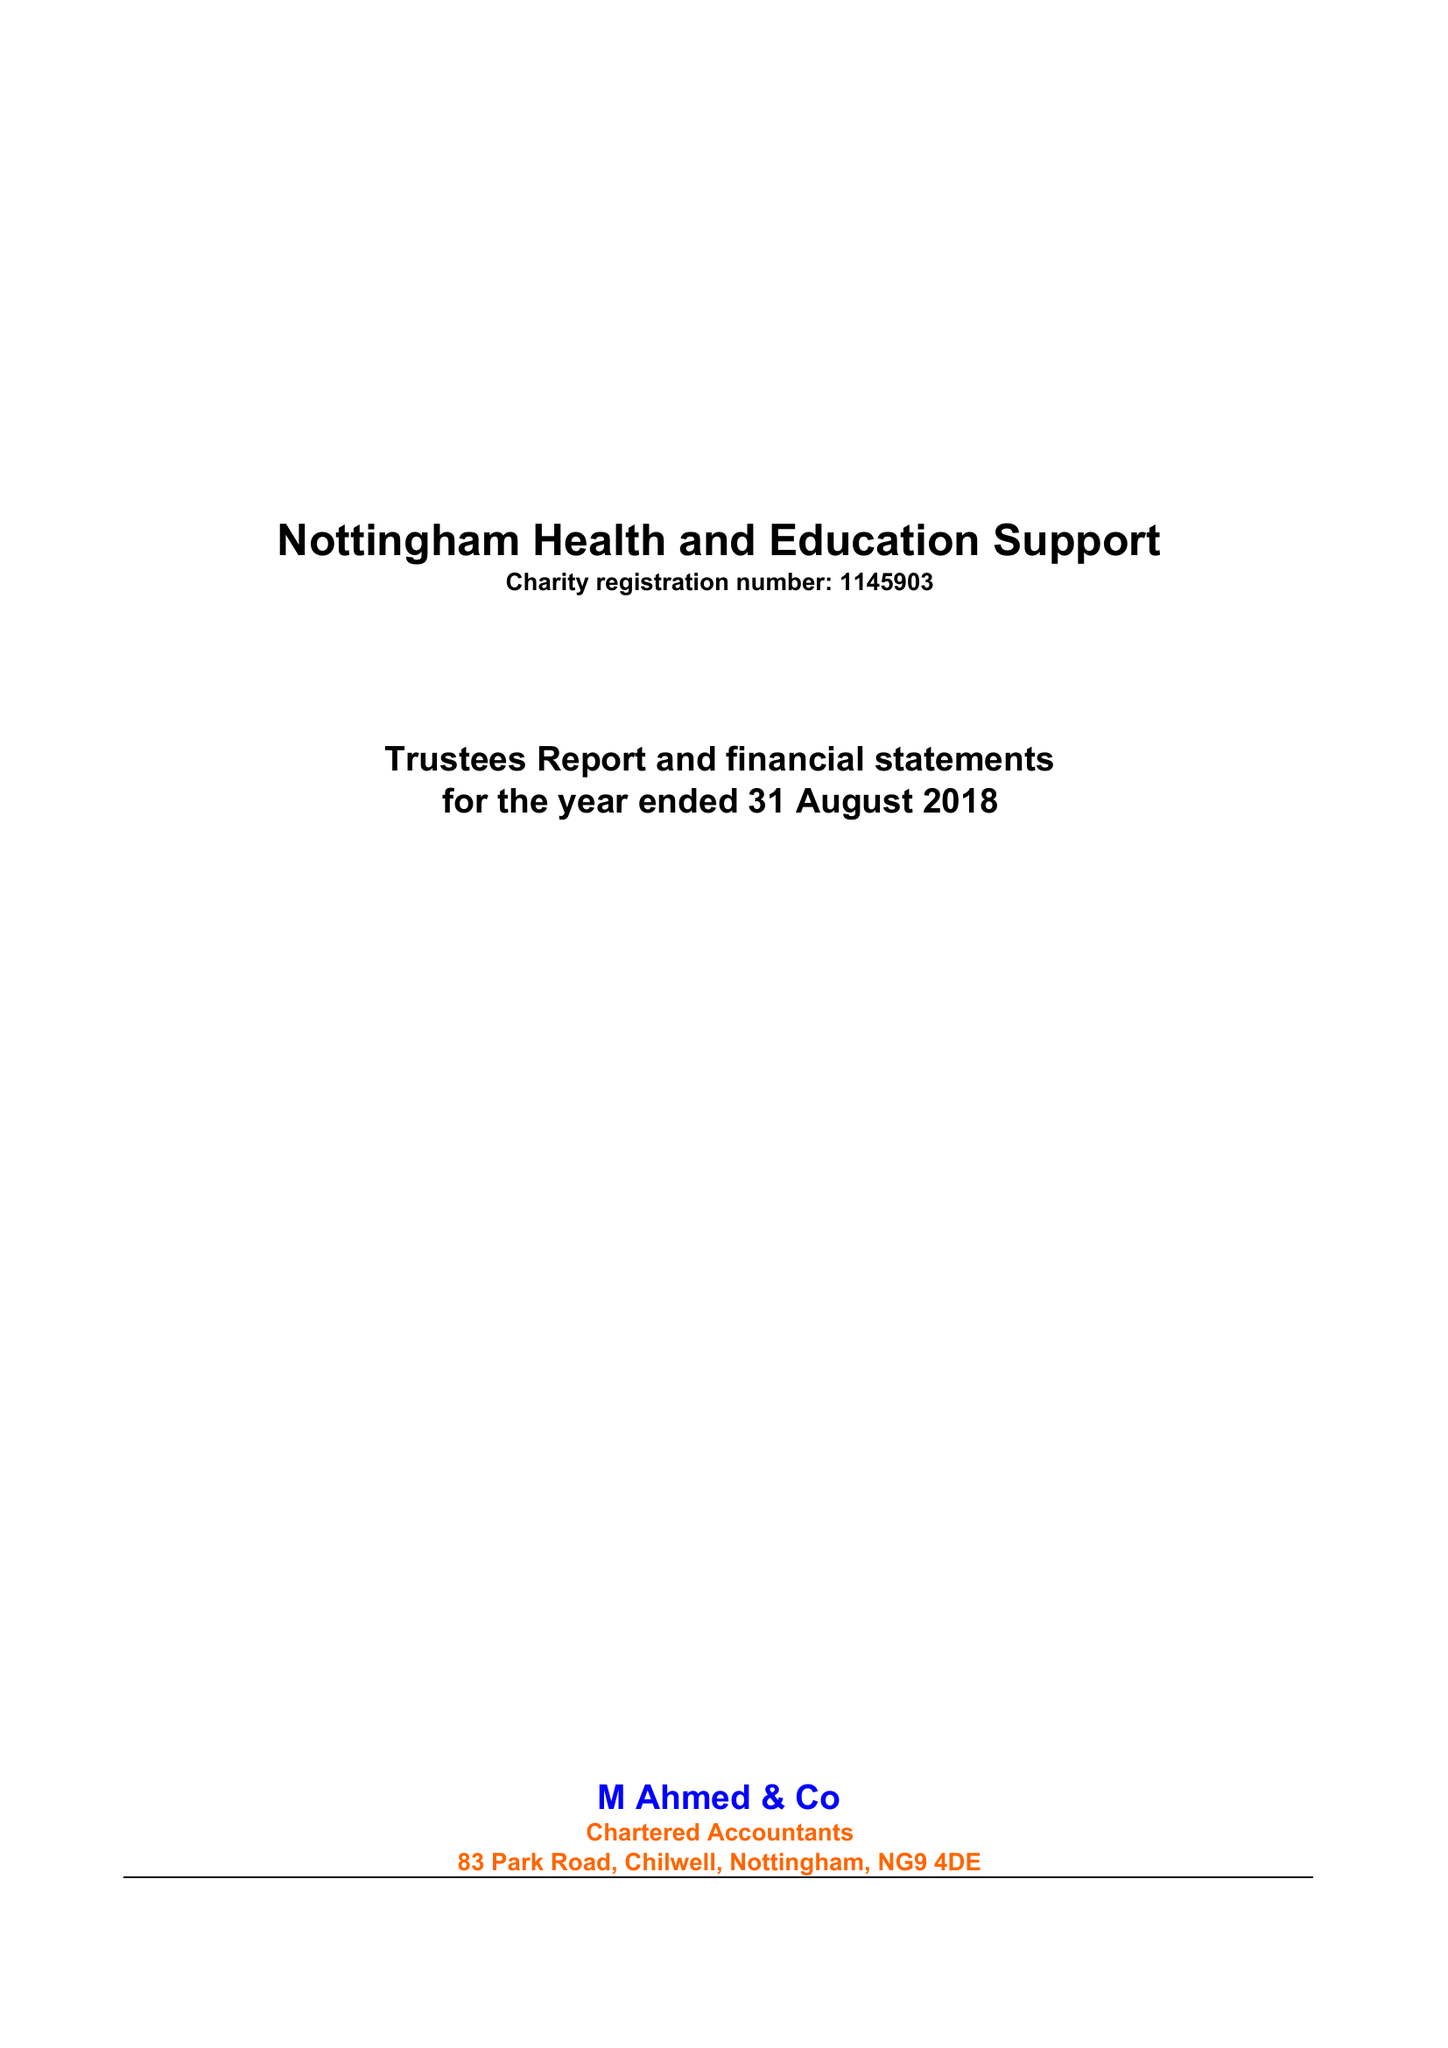What is the value for the address__street_line?
Answer the question using a single word or phrase. 9 CLAYGATE 